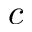Convert formula to latex. <formula><loc_0><loc_0><loc_500><loc_500>c</formula> 